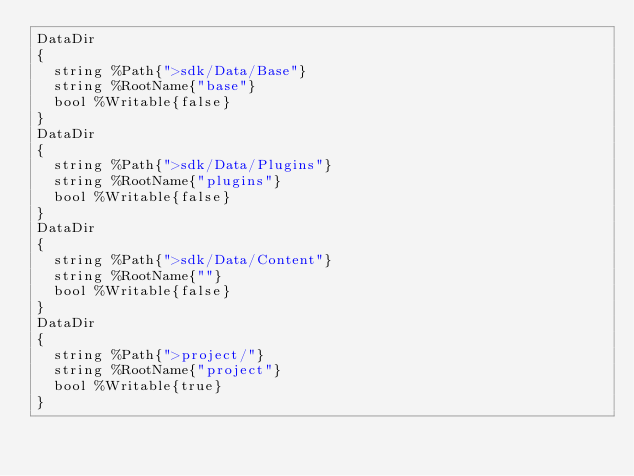Convert code to text. <code><loc_0><loc_0><loc_500><loc_500><_SQL_>DataDir
{
	string %Path{">sdk/Data/Base"}
	string %RootName{"base"}
	bool %Writable{false}
}
DataDir
{
	string %Path{">sdk/Data/Plugins"}
	string %RootName{"plugins"}
	bool %Writable{false}
}
DataDir
{
	string %Path{">sdk/Data/Content"}
	string %RootName{""}
	bool %Writable{false}
}
DataDir
{
	string %Path{">project/"}
	string %RootName{"project"}
	bool %Writable{true}
}
</code> 